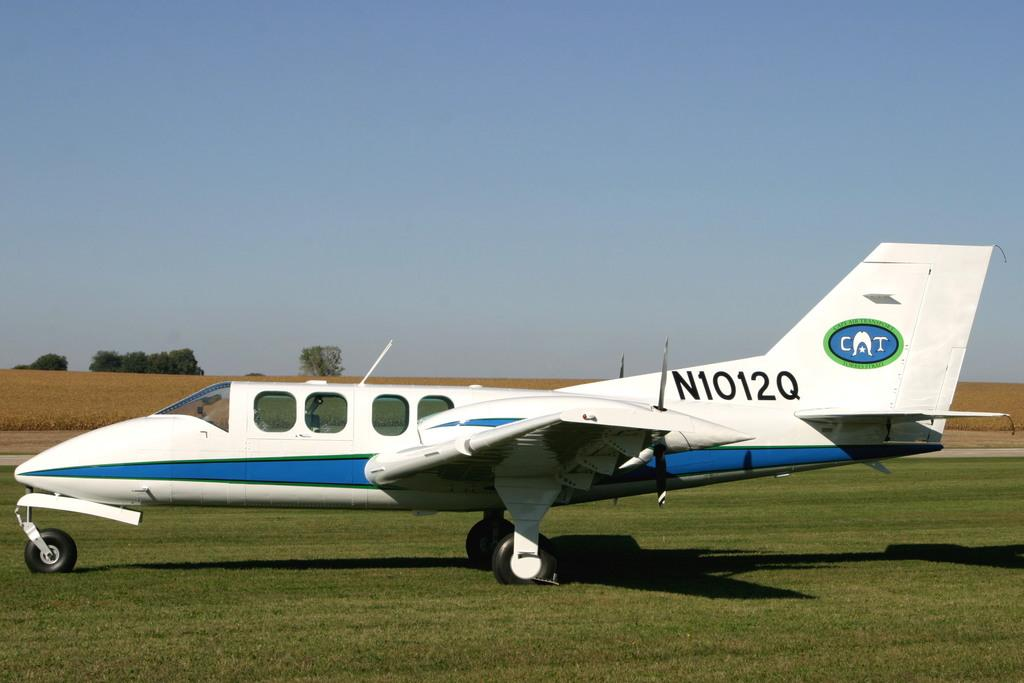What is the main subject of the image? The main subject of the image is an airplane on the ground. What can be seen in the background of the image? There are trees and the sky visible in the background of the image. What type of terrain is visible on the ground in the image? There is grass visible on the ground in the image. What else can be observed on the ground in the image? There are shadows on the ground in the image. What type of soda can be seen being poured into a glass in the image? There is no soda or glass present in the image; it features an airplane on the ground with trees, sky, grass, and shadows. 